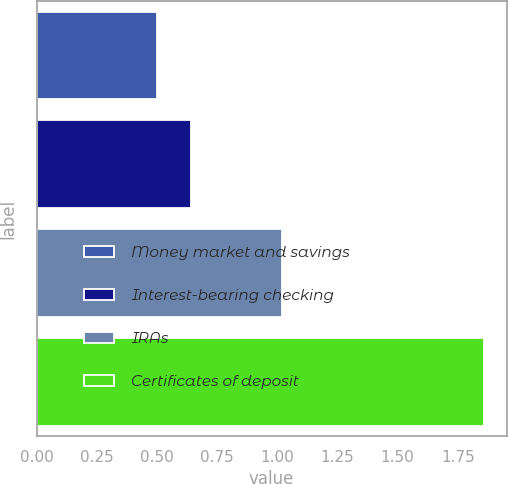Convert chart. <chart><loc_0><loc_0><loc_500><loc_500><bar_chart><fcel>Money market and savings<fcel>Interest-bearing checking<fcel>IRAs<fcel>Certificates of deposit<nl><fcel>0.5<fcel>0.64<fcel>1.02<fcel>1.86<nl></chart> 